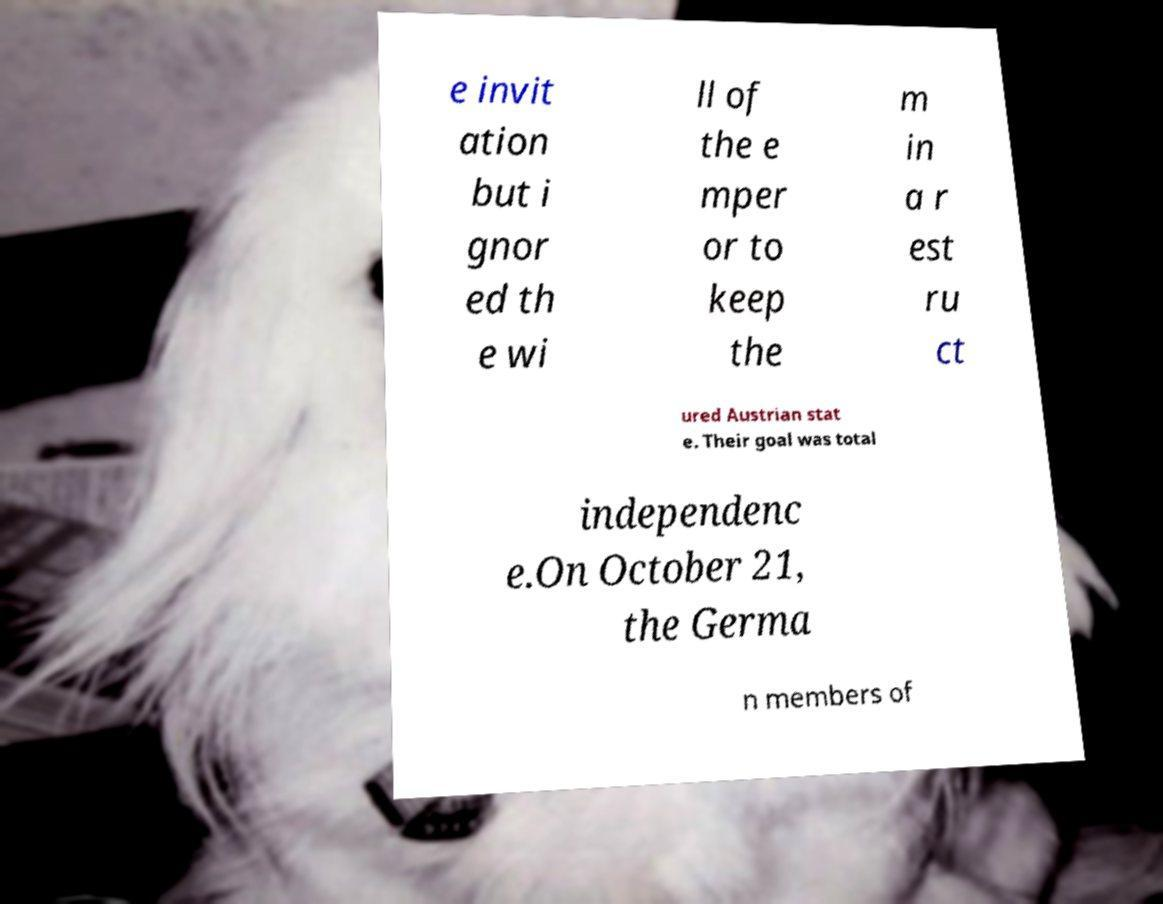Could you extract and type out the text from this image? e invit ation but i gnor ed th e wi ll of the e mper or to keep the m in a r est ru ct ured Austrian stat e. Their goal was total independenc e.On October 21, the Germa n members of 